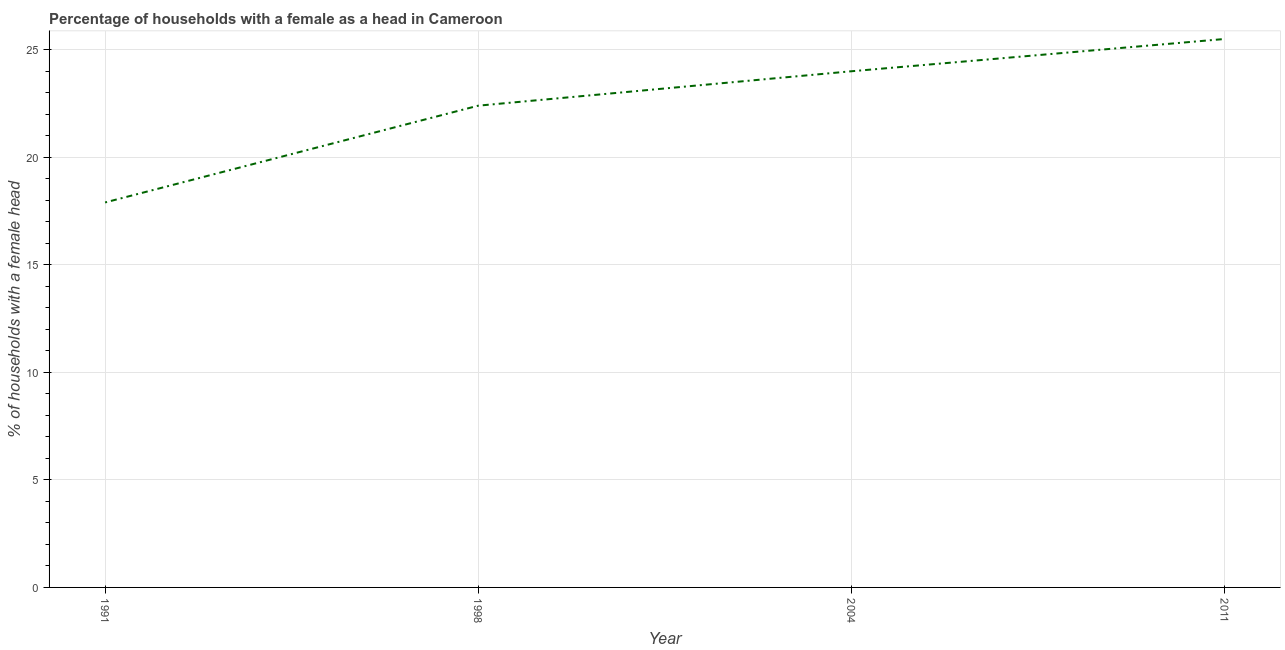Across all years, what is the maximum number of female supervised households?
Ensure brevity in your answer.  25.5. In which year was the number of female supervised households maximum?
Provide a succinct answer. 2011. In which year was the number of female supervised households minimum?
Your answer should be very brief. 1991. What is the sum of the number of female supervised households?
Your response must be concise. 89.8. What is the average number of female supervised households per year?
Your answer should be compact. 22.45. What is the median number of female supervised households?
Your response must be concise. 23.2. What is the ratio of the number of female supervised households in 1991 to that in 2011?
Offer a terse response. 0.7. Is the number of female supervised households in 1991 less than that in 2011?
Make the answer very short. Yes. Is the difference between the number of female supervised households in 1991 and 1998 greater than the difference between any two years?
Provide a short and direct response. No. What is the difference between the highest and the second highest number of female supervised households?
Offer a terse response. 1.5. Is the sum of the number of female supervised households in 1998 and 2004 greater than the maximum number of female supervised households across all years?
Offer a terse response. Yes. What is the difference between the highest and the lowest number of female supervised households?
Your answer should be very brief. 7.6. In how many years, is the number of female supervised households greater than the average number of female supervised households taken over all years?
Offer a terse response. 2. Does the number of female supervised households monotonically increase over the years?
Keep it short and to the point. Yes. Are the values on the major ticks of Y-axis written in scientific E-notation?
Your response must be concise. No. What is the title of the graph?
Make the answer very short. Percentage of households with a female as a head in Cameroon. What is the label or title of the X-axis?
Make the answer very short. Year. What is the label or title of the Y-axis?
Offer a very short reply. % of households with a female head. What is the % of households with a female head in 1991?
Provide a short and direct response. 17.9. What is the % of households with a female head of 1998?
Make the answer very short. 22.4. What is the difference between the % of households with a female head in 1991 and 1998?
Your answer should be very brief. -4.5. What is the difference between the % of households with a female head in 1991 and 2004?
Offer a very short reply. -6.1. What is the difference between the % of households with a female head in 1998 and 2004?
Offer a terse response. -1.6. What is the difference between the % of households with a female head in 1998 and 2011?
Your answer should be very brief. -3.1. What is the ratio of the % of households with a female head in 1991 to that in 1998?
Ensure brevity in your answer.  0.8. What is the ratio of the % of households with a female head in 1991 to that in 2004?
Offer a very short reply. 0.75. What is the ratio of the % of households with a female head in 1991 to that in 2011?
Make the answer very short. 0.7. What is the ratio of the % of households with a female head in 1998 to that in 2004?
Your response must be concise. 0.93. What is the ratio of the % of households with a female head in 1998 to that in 2011?
Offer a very short reply. 0.88. What is the ratio of the % of households with a female head in 2004 to that in 2011?
Keep it short and to the point. 0.94. 